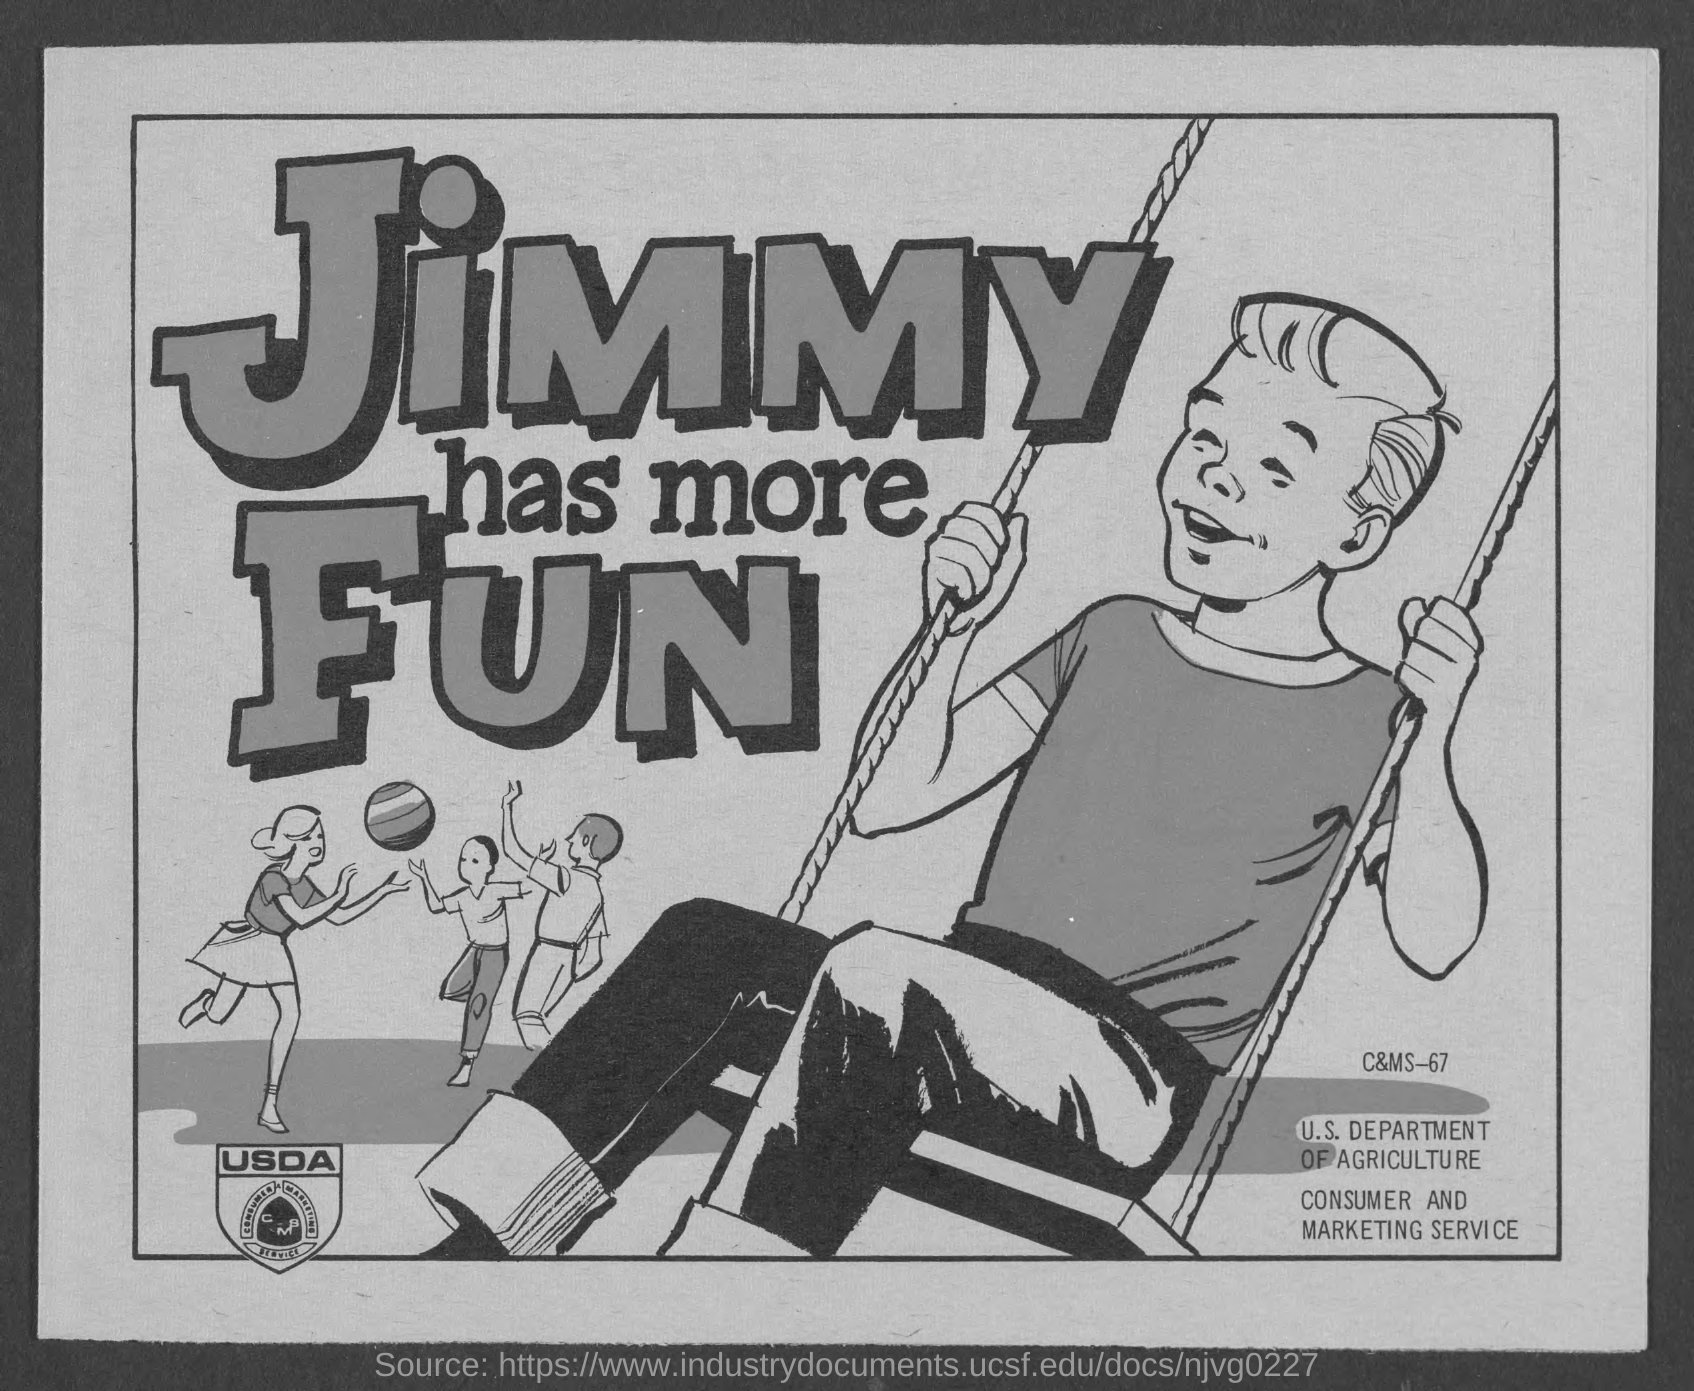Give some essential details in this illustration. What is C&MS number 67?" is a question asking for information about a specific C&MS number. 